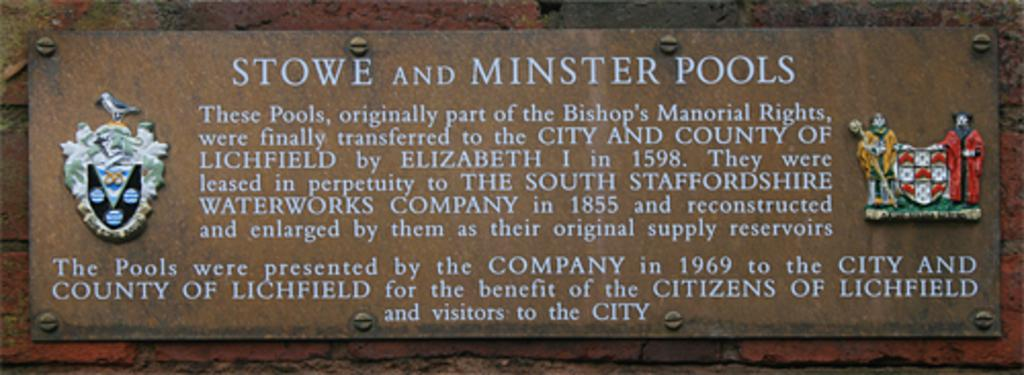What is the main object in the center of the image? There is a board in the center of the image. What is written or depicted on the board? There is text on the board. Are there any additional items on the board? Yes, there are toys on the board. What can be seen in the background of the image? There is a wall in the background of the image. What type of force is being applied to the board in the image? There is no indication of any force being applied to the board in the image. Can you tell me how many forks are visible on the board? There are no forks present on the board in the image. 